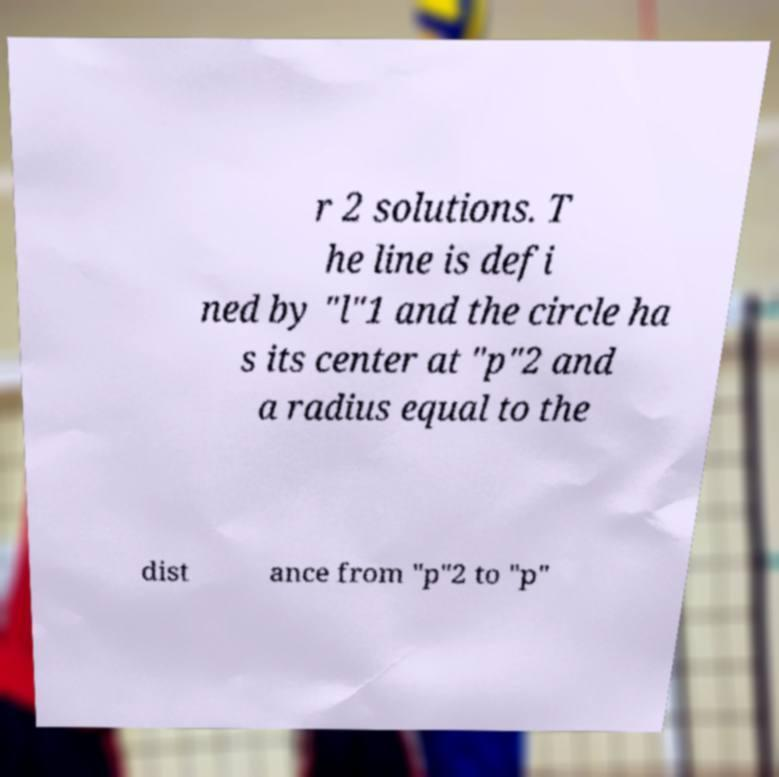Can you accurately transcribe the text from the provided image for me? r 2 solutions. T he line is defi ned by "l"1 and the circle ha s its center at "p"2 and a radius equal to the dist ance from "p"2 to "p" 